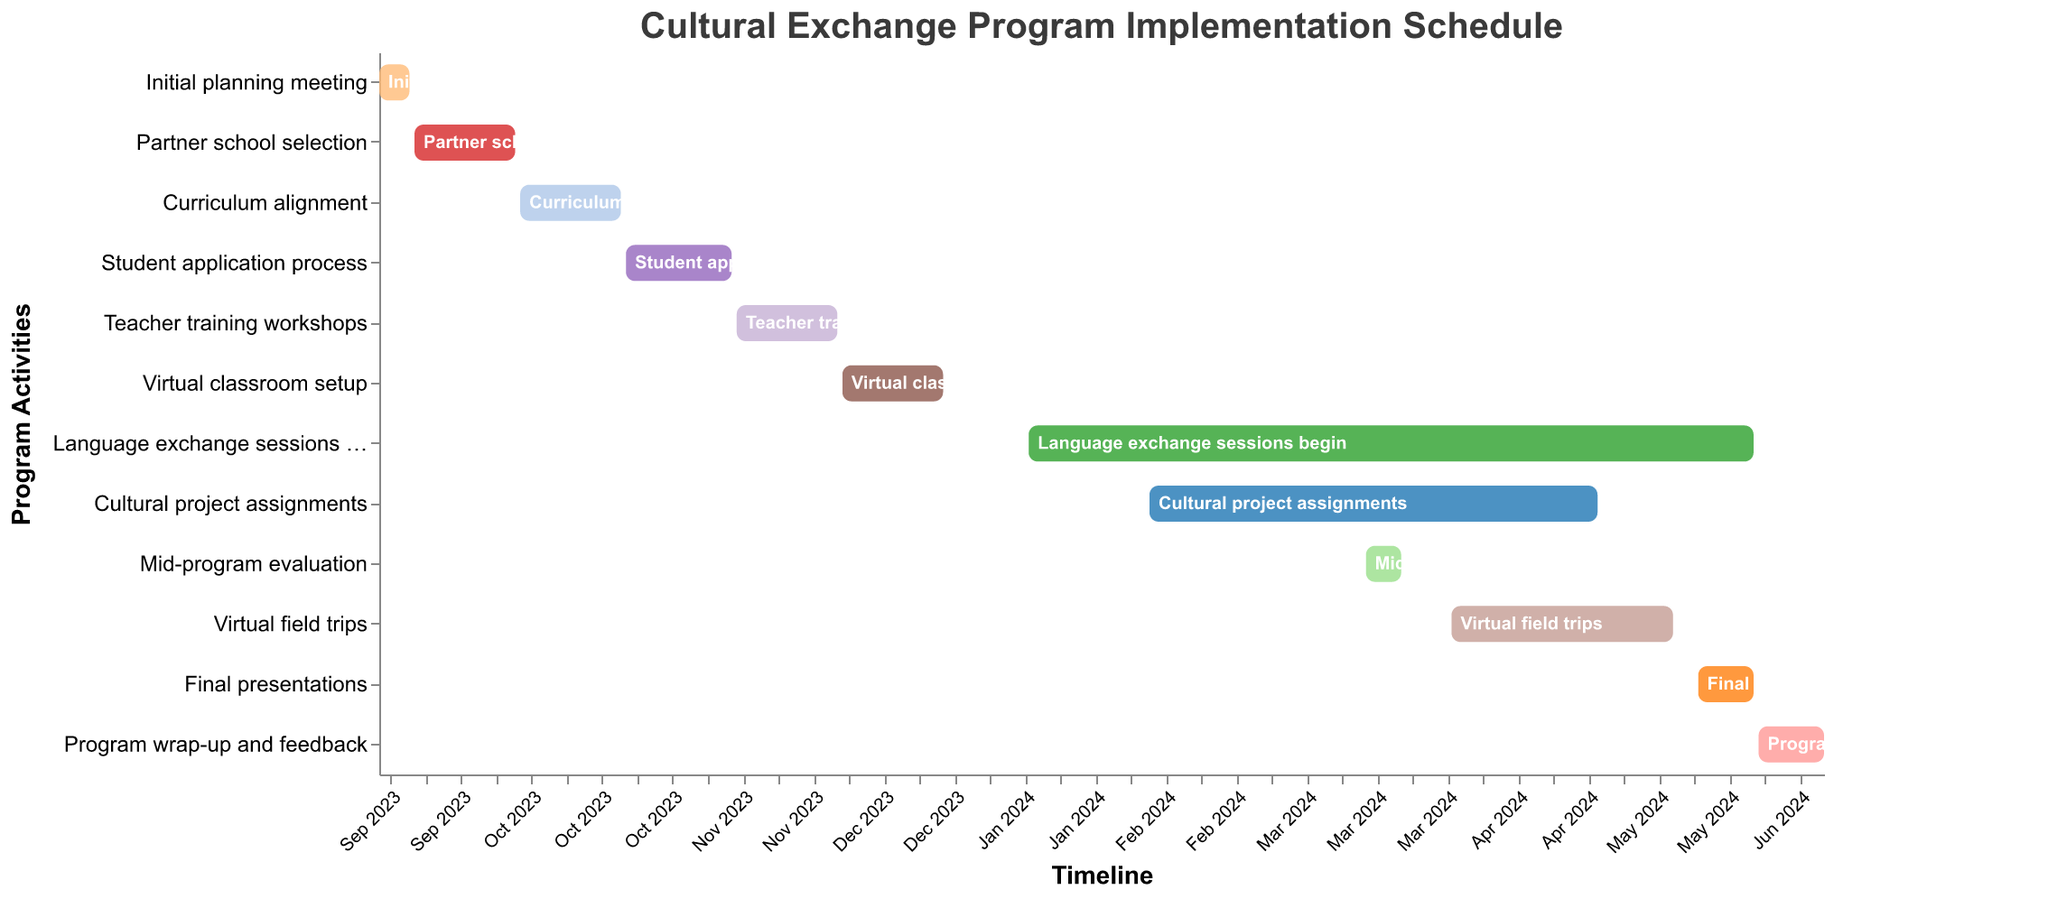What is the title of the Gantt chart? The title is prominently displayed at the top of the chart. It uses a larger font size and bold weight for emphasis. The title is centered and colored in a distinct shade.
Answer: Cultural Exchange Program Implementation Schedule Which task starts first in the schedule? The "Initial planning meeting" task is positioned at the top and starts on September 1, 2023. The tasks are sorted chronologically by their start dates, making it easy to identify the first task.
Answer: Initial planning meeting For how long does the "Teacher training workshops" task run? The duration is calculated by subtracting the start date from the end date. The "Teacher training workshops" task starts on November 11, 2023, and ends on December 1, 2023.
Answer: 21 days Which tasks are scheduled to occur in April 2024? We look for tasks whose timelines overlap with April 2024. "Cultural project assignments" run until April 30, 2024, "Virtual field trips" start on April 1, 2024, and "Language exchange sessions begin" also include April.
Answer: Cultural project assignments, Virtual field trips, Language exchange sessions begin Are there any tasks that start in 2023 and end in 2024? Check tasks that start in 2023 and have an end date in 2024. The "Language exchange sessions begin" task starts on January 8, 2024, and runs through May 31, 2024.
Answer: No such task exists What task has the longest duration? To determine the longest duration, subtract the start date from the end date for each task. The "Language exchange sessions begin" task runs from January 8, 2024, to May 31, 2024, totaling 144 days.
Answer: Language exchange sessions begin What tasks will be running concurrently with the "Mid-program evaluation"? Identify tasks that overlap with the "Mid-program evaluation" timeline, which runs from March 15, 2024, to March 22, 2024. The tasks are "Language exchange sessions begin" and "Cultural project assignments".
Answer: Language exchange sessions begin, Cultural project assignments How many tasks are there in total? Count the number of distinct tasks listed in the y-axis or in the data values section.
Answer: 12 tasks When does the "Final presentations" task start and end? Refer to the task labeled "Final presentations" on the Gantt chart. It starts on May 20, 2024, and ends on May 31, 2024.
Answer: May 20, 2024, to May 31, 2024 